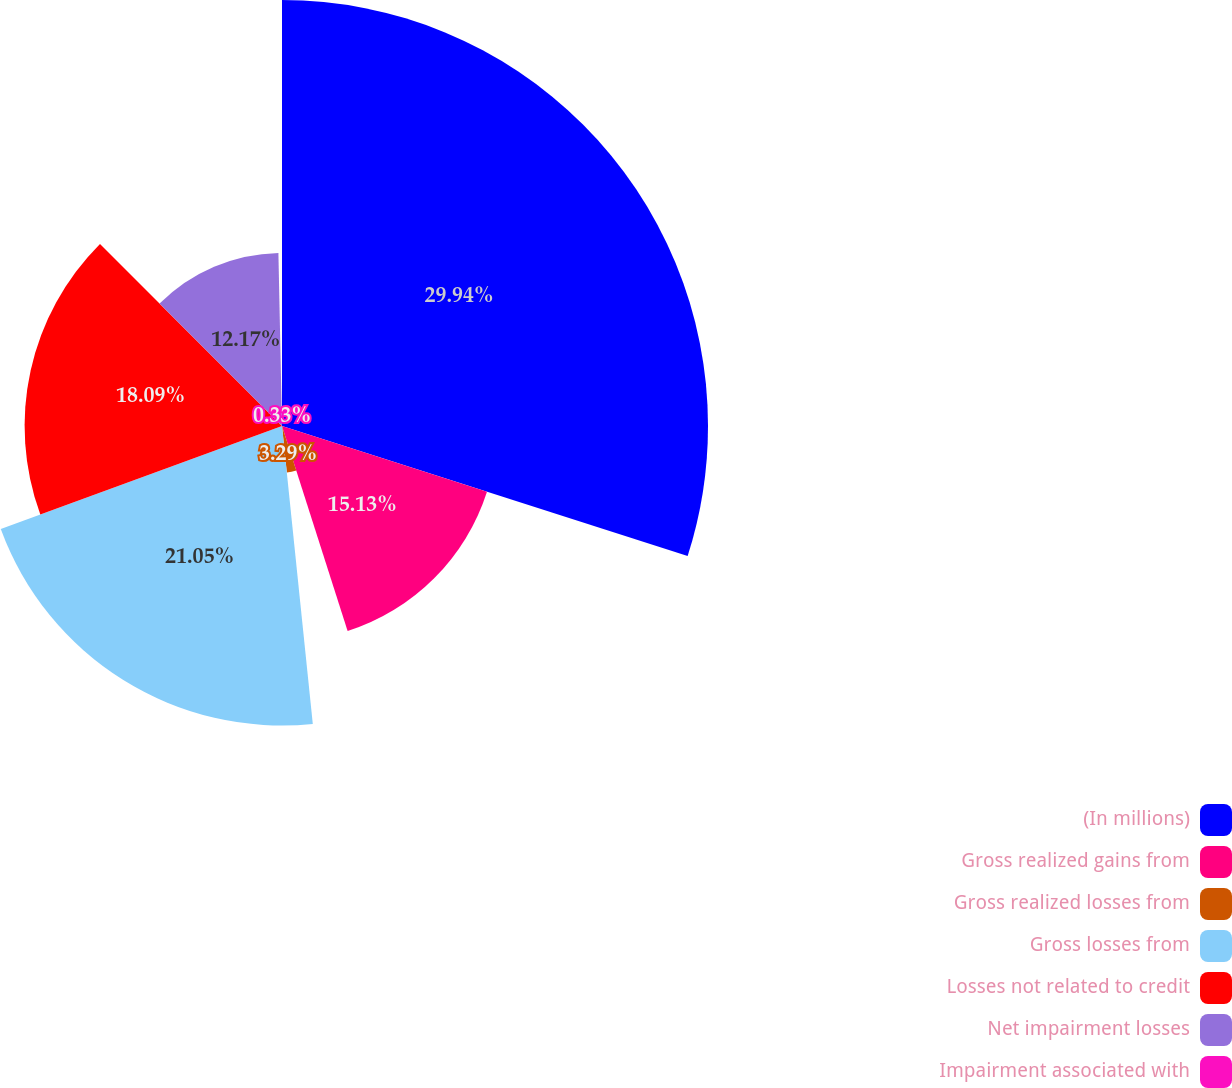Convert chart. <chart><loc_0><loc_0><loc_500><loc_500><pie_chart><fcel>(In millions)<fcel>Gross realized gains from<fcel>Gross realized losses from<fcel>Gross losses from<fcel>Losses not related to credit<fcel>Net impairment losses<fcel>Impairment associated with<nl><fcel>29.94%<fcel>15.13%<fcel>3.29%<fcel>21.05%<fcel>18.09%<fcel>12.17%<fcel>0.33%<nl></chart> 